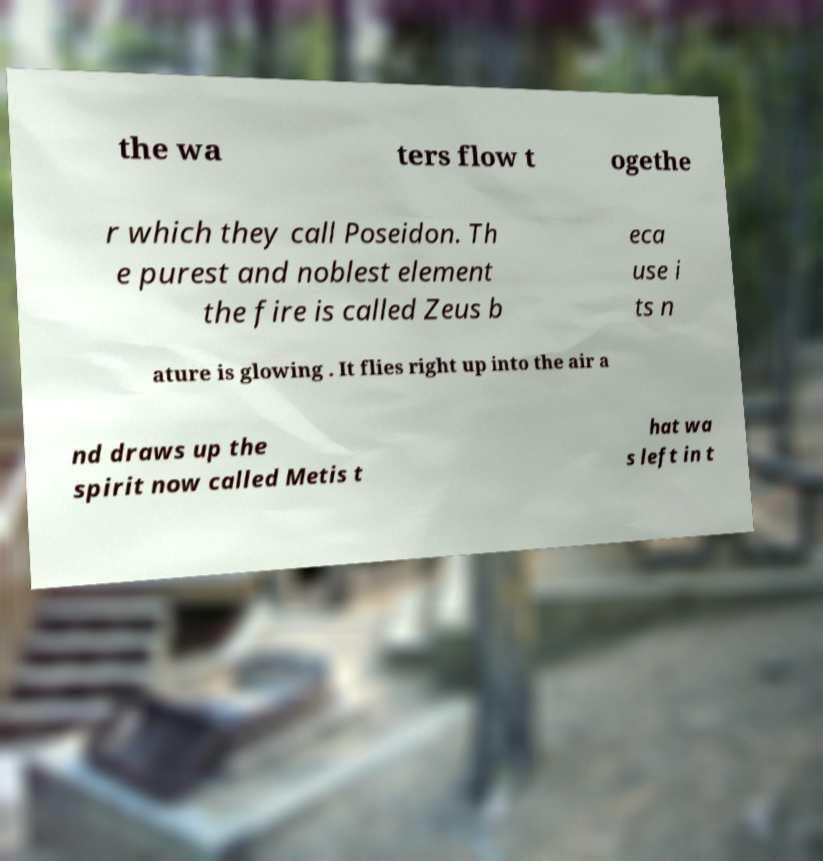Please read and relay the text visible in this image. What does it say? the wa ters flow t ogethe r which they call Poseidon. Th e purest and noblest element the fire is called Zeus b eca use i ts n ature is glowing . It flies right up into the air a nd draws up the spirit now called Metis t hat wa s left in t 